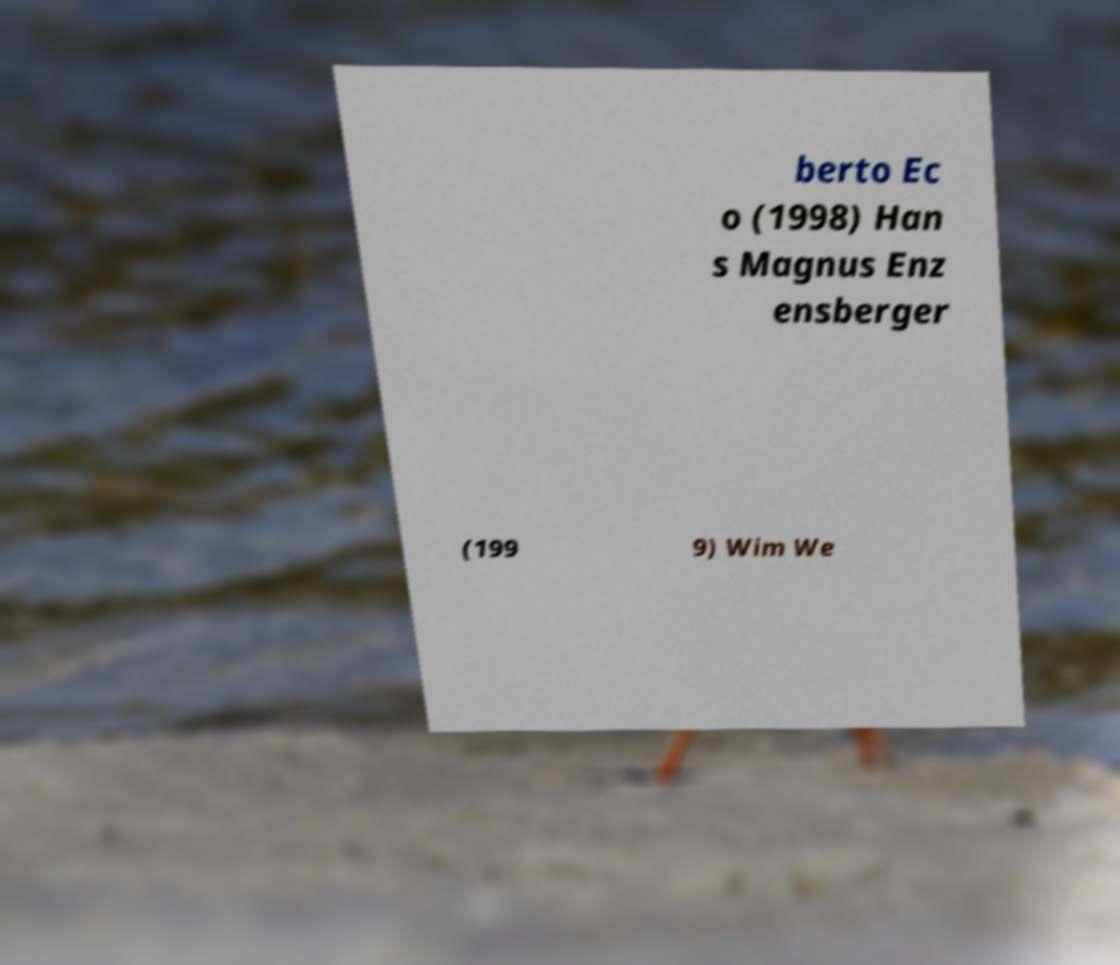There's text embedded in this image that I need extracted. Can you transcribe it verbatim? berto Ec o (1998) Han s Magnus Enz ensberger (199 9) Wim We 